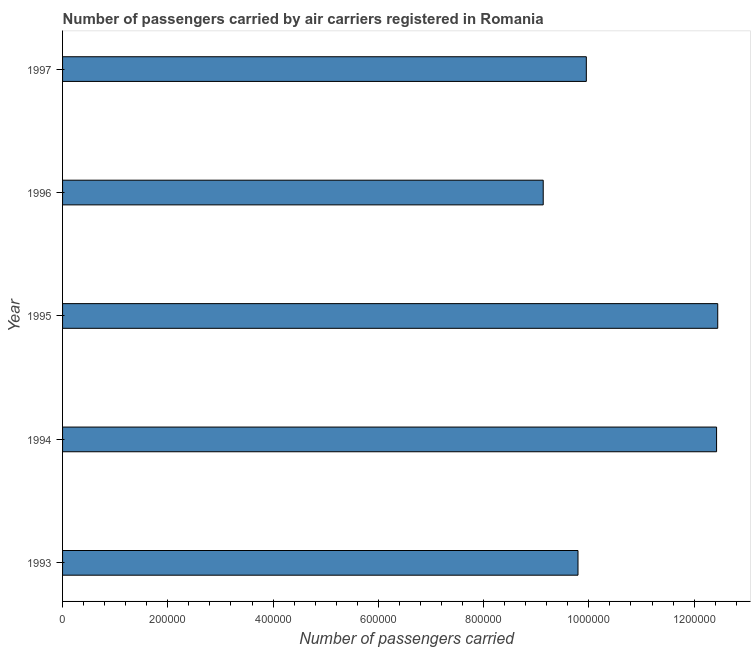Does the graph contain any zero values?
Offer a very short reply. No. What is the title of the graph?
Make the answer very short. Number of passengers carried by air carriers registered in Romania. What is the label or title of the X-axis?
Your response must be concise. Number of passengers carried. What is the number of passengers carried in 1994?
Give a very brief answer. 1.24e+06. Across all years, what is the maximum number of passengers carried?
Provide a succinct answer. 1.24e+06. Across all years, what is the minimum number of passengers carried?
Your response must be concise. 9.13e+05. What is the sum of the number of passengers carried?
Offer a terse response. 5.38e+06. What is the difference between the number of passengers carried in 1993 and 1995?
Provide a succinct answer. -2.66e+05. What is the average number of passengers carried per year?
Give a very brief answer. 1.08e+06. What is the median number of passengers carried?
Provide a short and direct response. 9.95e+05. Is the difference between the number of passengers carried in 1995 and 1997 greater than the difference between any two years?
Your answer should be compact. No. What is the difference between the highest and the second highest number of passengers carried?
Your answer should be very brief. 2200. What is the difference between the highest and the lowest number of passengers carried?
Offer a terse response. 3.32e+05. Are all the bars in the graph horizontal?
Make the answer very short. Yes. What is the difference between two consecutive major ticks on the X-axis?
Your answer should be very brief. 2.00e+05. What is the Number of passengers carried in 1993?
Provide a short and direct response. 9.79e+05. What is the Number of passengers carried of 1994?
Offer a terse response. 1.24e+06. What is the Number of passengers carried of 1995?
Ensure brevity in your answer.  1.24e+06. What is the Number of passengers carried in 1996?
Your response must be concise. 9.13e+05. What is the Number of passengers carried of 1997?
Provide a short and direct response. 9.95e+05. What is the difference between the Number of passengers carried in 1993 and 1994?
Your answer should be compact. -2.63e+05. What is the difference between the Number of passengers carried in 1993 and 1995?
Offer a terse response. -2.66e+05. What is the difference between the Number of passengers carried in 1993 and 1996?
Provide a succinct answer. 6.61e+04. What is the difference between the Number of passengers carried in 1993 and 1997?
Your response must be concise. -1.58e+04. What is the difference between the Number of passengers carried in 1994 and 1995?
Keep it short and to the point. -2200. What is the difference between the Number of passengers carried in 1994 and 1996?
Ensure brevity in your answer.  3.29e+05. What is the difference between the Number of passengers carried in 1994 and 1997?
Keep it short and to the point. 2.48e+05. What is the difference between the Number of passengers carried in 1995 and 1996?
Your answer should be compact. 3.32e+05. What is the difference between the Number of passengers carried in 1995 and 1997?
Your answer should be compact. 2.50e+05. What is the difference between the Number of passengers carried in 1996 and 1997?
Ensure brevity in your answer.  -8.19e+04. What is the ratio of the Number of passengers carried in 1993 to that in 1994?
Your response must be concise. 0.79. What is the ratio of the Number of passengers carried in 1993 to that in 1995?
Ensure brevity in your answer.  0.79. What is the ratio of the Number of passengers carried in 1993 to that in 1996?
Offer a very short reply. 1.07. What is the ratio of the Number of passengers carried in 1993 to that in 1997?
Make the answer very short. 0.98. What is the ratio of the Number of passengers carried in 1994 to that in 1996?
Offer a terse response. 1.36. What is the ratio of the Number of passengers carried in 1994 to that in 1997?
Offer a very short reply. 1.25. What is the ratio of the Number of passengers carried in 1995 to that in 1996?
Provide a short and direct response. 1.36. What is the ratio of the Number of passengers carried in 1995 to that in 1997?
Your answer should be very brief. 1.25. What is the ratio of the Number of passengers carried in 1996 to that in 1997?
Provide a short and direct response. 0.92. 